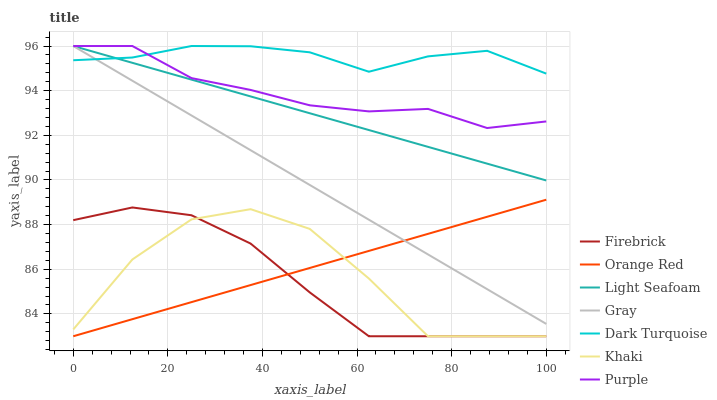Does Firebrick have the minimum area under the curve?
Answer yes or no. Yes. Does Dark Turquoise have the maximum area under the curve?
Answer yes or no. Yes. Does Khaki have the minimum area under the curve?
Answer yes or no. No. Does Khaki have the maximum area under the curve?
Answer yes or no. No. Is Light Seafoam the smoothest?
Answer yes or no. Yes. Is Khaki the roughest?
Answer yes or no. Yes. Is Purple the smoothest?
Answer yes or no. No. Is Purple the roughest?
Answer yes or no. No. Does Khaki have the lowest value?
Answer yes or no. Yes. Does Purple have the lowest value?
Answer yes or no. No. Does Light Seafoam have the highest value?
Answer yes or no. Yes. Does Khaki have the highest value?
Answer yes or no. No. Is Khaki less than Light Seafoam?
Answer yes or no. Yes. Is Dark Turquoise greater than Orange Red?
Answer yes or no. Yes. Does Dark Turquoise intersect Gray?
Answer yes or no. Yes. Is Dark Turquoise less than Gray?
Answer yes or no. No. Is Dark Turquoise greater than Gray?
Answer yes or no. No. Does Khaki intersect Light Seafoam?
Answer yes or no. No. 